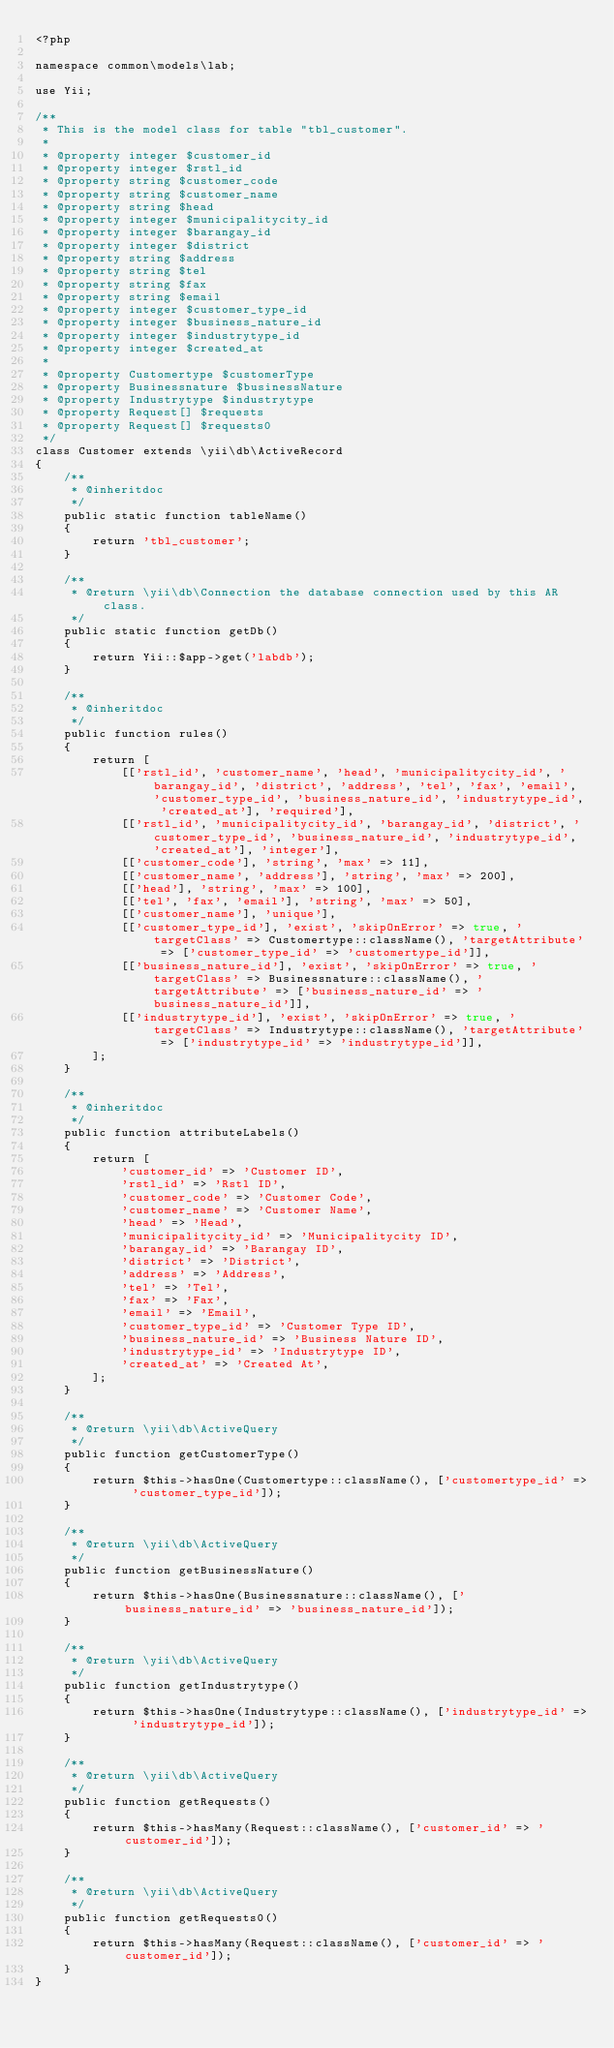<code> <loc_0><loc_0><loc_500><loc_500><_PHP_><?php

namespace common\models\lab;

use Yii;

/**
 * This is the model class for table "tbl_customer".
 *
 * @property integer $customer_id
 * @property integer $rstl_id
 * @property string $customer_code
 * @property string $customer_name
 * @property string $head
 * @property integer $municipalitycity_id
 * @property integer $barangay_id
 * @property integer $district
 * @property string $address
 * @property string $tel
 * @property string $fax
 * @property string $email
 * @property integer $customer_type_id
 * @property integer $business_nature_id
 * @property integer $industrytype_id
 * @property integer $created_at
 *
 * @property Customertype $customerType
 * @property Businessnature $businessNature
 * @property Industrytype $industrytype
 * @property Request[] $requests
 * @property Request[] $requests0
 */
class Customer extends \yii\db\ActiveRecord
{
    /**
     * @inheritdoc
     */
    public static function tableName()
    {
        return 'tbl_customer';
    }

    /**
     * @return \yii\db\Connection the database connection used by this AR class.
     */
    public static function getDb()
    {
        return Yii::$app->get('labdb');
    }

    /**
     * @inheritdoc
     */
    public function rules()
    {
        return [
            [['rstl_id', 'customer_name', 'head', 'municipalitycity_id', 'barangay_id', 'district', 'address', 'tel', 'fax', 'email', 'customer_type_id', 'business_nature_id', 'industrytype_id', 'created_at'], 'required'],
            [['rstl_id', 'municipalitycity_id', 'barangay_id', 'district', 'customer_type_id', 'business_nature_id', 'industrytype_id', 'created_at'], 'integer'],
            [['customer_code'], 'string', 'max' => 11],
            [['customer_name', 'address'], 'string', 'max' => 200],
            [['head'], 'string', 'max' => 100],
            [['tel', 'fax', 'email'], 'string', 'max' => 50],
            [['customer_name'], 'unique'],
            [['customer_type_id'], 'exist', 'skipOnError' => true, 'targetClass' => Customertype::className(), 'targetAttribute' => ['customer_type_id' => 'customertype_id']],
            [['business_nature_id'], 'exist', 'skipOnError' => true, 'targetClass' => Businessnature::className(), 'targetAttribute' => ['business_nature_id' => 'business_nature_id']],
            [['industrytype_id'], 'exist', 'skipOnError' => true, 'targetClass' => Industrytype::className(), 'targetAttribute' => ['industrytype_id' => 'industrytype_id']],
        ];
    }

    /**
     * @inheritdoc
     */
    public function attributeLabels()
    {
        return [
            'customer_id' => 'Customer ID',
            'rstl_id' => 'Rstl ID',
            'customer_code' => 'Customer Code',
            'customer_name' => 'Customer Name',
            'head' => 'Head',
            'municipalitycity_id' => 'Municipalitycity ID',
            'barangay_id' => 'Barangay ID',
            'district' => 'District',
            'address' => 'Address',
            'tel' => 'Tel',
            'fax' => 'Fax',
            'email' => 'Email',
            'customer_type_id' => 'Customer Type ID',
            'business_nature_id' => 'Business Nature ID',
            'industrytype_id' => 'Industrytype ID',
            'created_at' => 'Created At',
        ];
    }

    /**
     * @return \yii\db\ActiveQuery
     */
    public function getCustomerType()
    {
        return $this->hasOne(Customertype::className(), ['customertype_id' => 'customer_type_id']);
    }

    /**
     * @return \yii\db\ActiveQuery
     */
    public function getBusinessNature()
    {
        return $this->hasOne(Businessnature::className(), ['business_nature_id' => 'business_nature_id']);
    }

    /**
     * @return \yii\db\ActiveQuery
     */
    public function getIndustrytype()
    {
        return $this->hasOne(Industrytype::className(), ['industrytype_id' => 'industrytype_id']);
    }

    /**
     * @return \yii\db\ActiveQuery
     */
    public function getRequests()
    {
        return $this->hasMany(Request::className(), ['customer_id' => 'customer_id']);
    }

    /**
     * @return \yii\db\ActiveQuery
     */
    public function getRequests0()
    {
        return $this->hasMany(Request::className(), ['customer_id' => 'customer_id']);
    }
}
</code> 